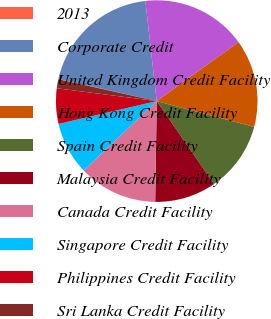Convert chart to OTSL. <chart><loc_0><loc_0><loc_500><loc_500><pie_chart><fcel>2013<fcel>Corporate Credit<fcel>United Kingdom Credit Facility<fcel>Hong Kong Credit Facility<fcel>Spain Credit Facility<fcel>Malaysia Credit Facility<fcel>Canada Credit Facility<fcel>Singapore Credit Facility<fcel>Philippines Credit Facility<fcel>Sri Lanka Credit Facility<nl><fcel>0.05%<fcel>19.67%<fcel>16.86%<fcel>14.06%<fcel>11.26%<fcel>9.86%<fcel>12.66%<fcel>8.46%<fcel>5.66%<fcel>1.45%<nl></chart> 